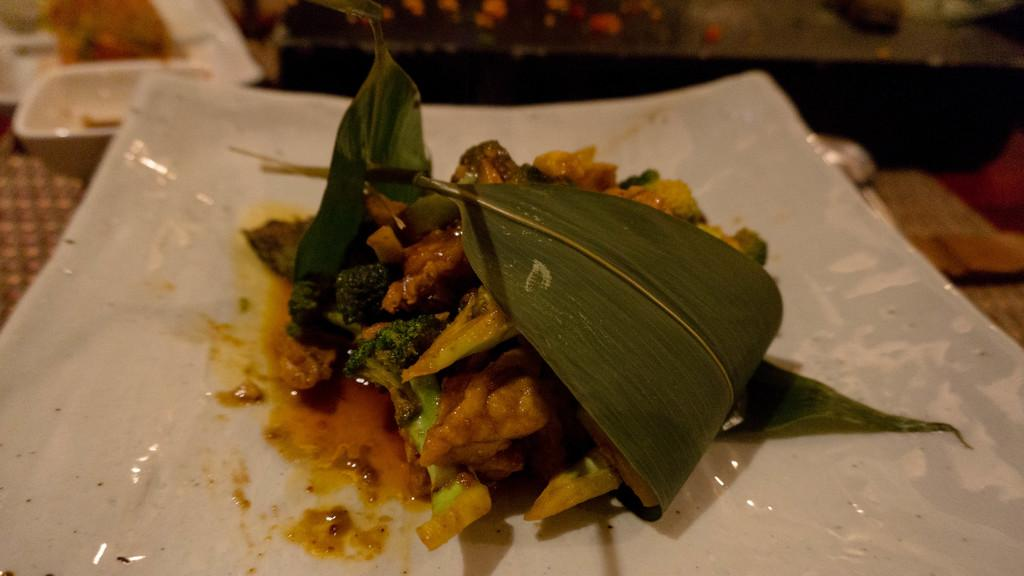What is the main subject of the image? There is a food item on a white color plate in the image. Can you describe the plate? The plate is white in color. What else can be seen in the image besides the food item and the plate? There are other objects visible in the background of the image. What type of drug is being prepared on the plate in the image? There is no drug present in the image; it is a food item on a white plate. What appliance is being used to cook the toad in the image? There is no toad or appliance present in the image; it is a food item on a white plate with other objects visible in the background. 